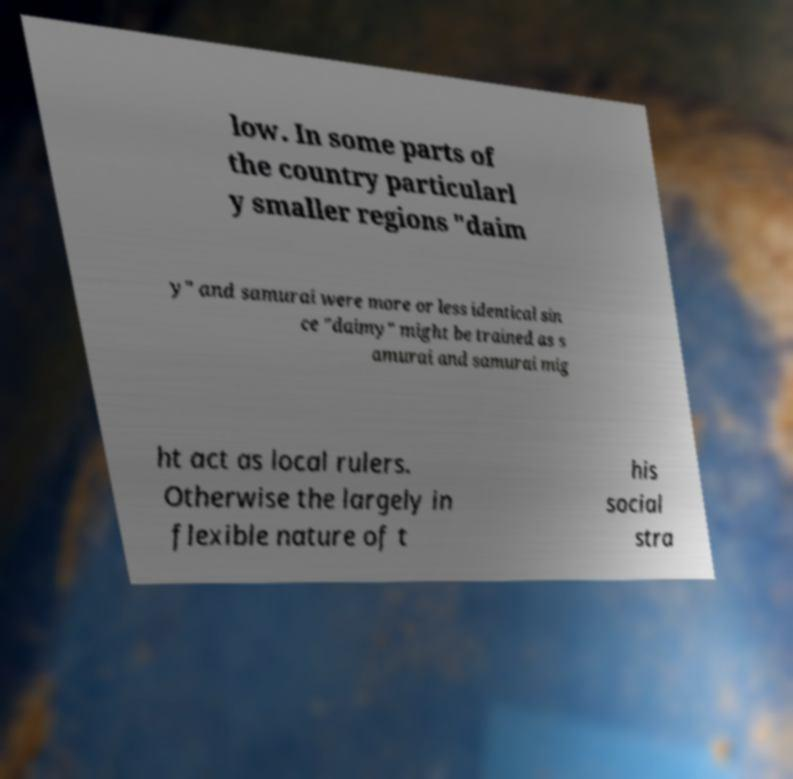I need the written content from this picture converted into text. Can you do that? low. In some parts of the country particularl y smaller regions "daim y" and samurai were more or less identical sin ce "daimy" might be trained as s amurai and samurai mig ht act as local rulers. Otherwise the largely in flexible nature of t his social stra 